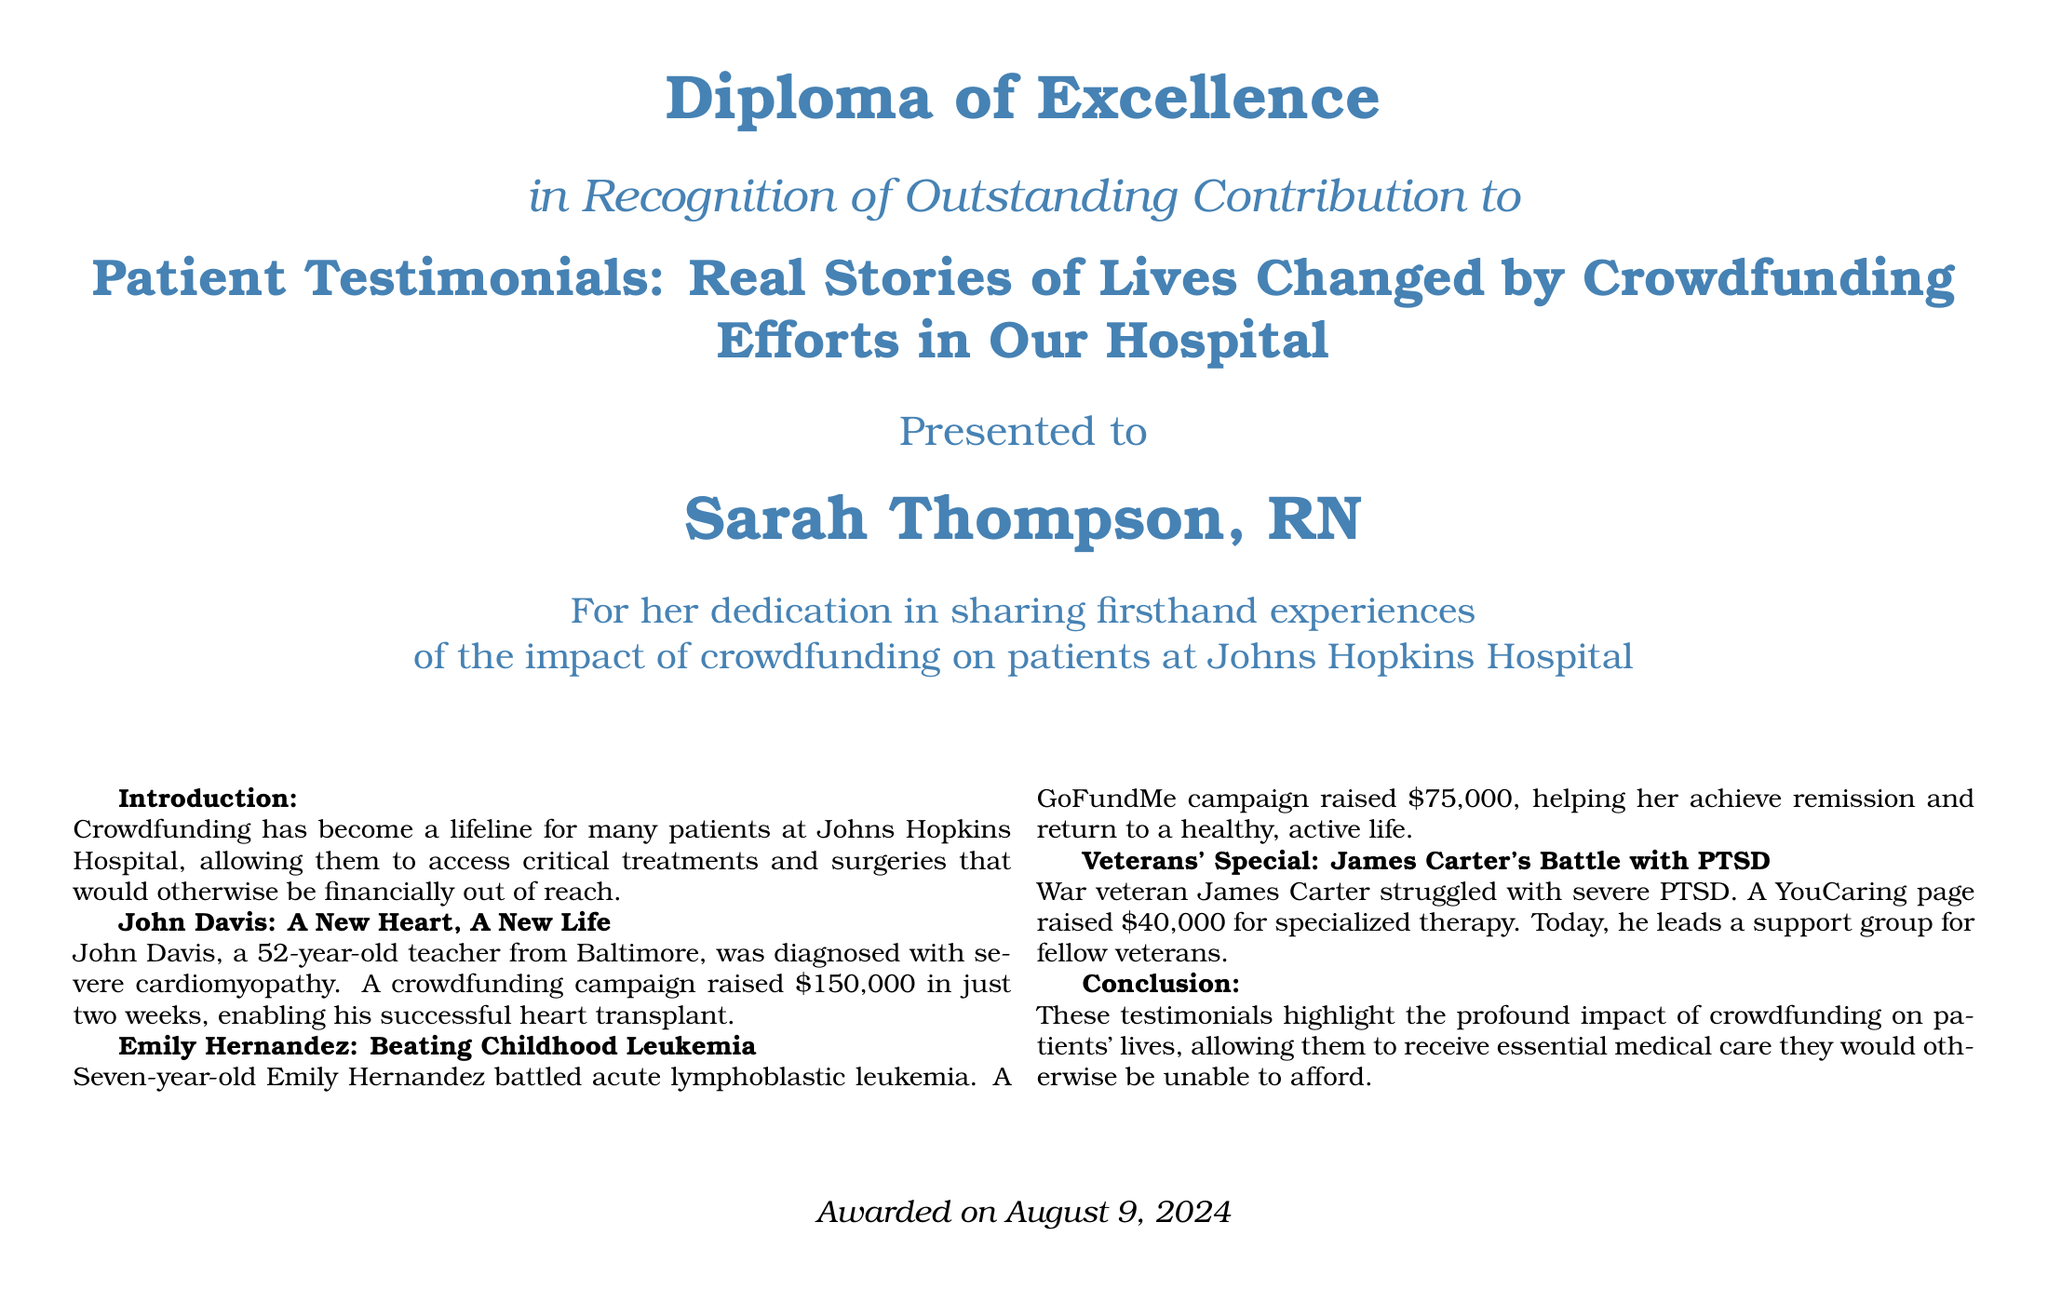What is the title of the diploma? The title of the diploma is prominently displayed as "Patient Testimonials: Real Stories of Lives Changed by Crowdfunding Efforts in Our Hospital."
Answer: Patient Testimonials: Real Stories of Lives Changed by Crowdfunding Efforts in Our Hospital Who is the recipient of the diploma? The document states that the diploma is presented to Sarah Thompson, RN.
Answer: Sarah Thompson, RN How much money was raised for John Davis's heart transplant? The document specifies that a crowdfunding campaign raised $150,000 for John Davis's heart transplant.
Answer: $150,000 What illness did Emily Hernandez battle? The document mentions that Emily Hernandez battled acute lymphoblastic leukemia.
Answer: acute lymphoblastic leukemia What amount was raised for James Carter's therapy? The document states that a YouCaring page raised $40,000 for James Carter's specialized therapy.
Answer: $40,000 What date was the diploma awarded? The document indicates that the diploma was awarded on today's date, as stated in the closing line.
Answer: today 